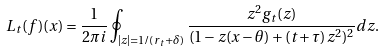<formula> <loc_0><loc_0><loc_500><loc_500>L _ { t } ( f ) ( x ) = \frac { 1 } { 2 \pi i } \oint _ { | z | = 1 / ( r _ { t } + \delta ) } \frac { z ^ { 2 } g _ { t } ( z ) } { ( 1 - z ( x - \theta ) + ( t + \tau ) z ^ { 2 } ) ^ { 2 } } d z .</formula> 